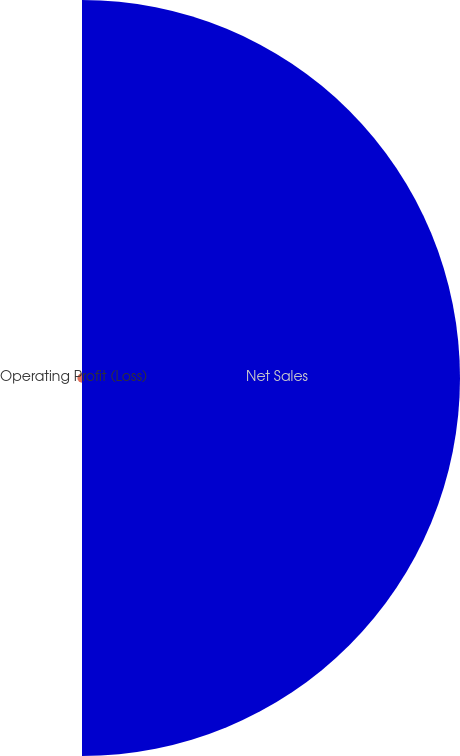Convert chart to OTSL. <chart><loc_0><loc_0><loc_500><loc_500><pie_chart><fcel>Net Sales<fcel>Operating Profit (Loss)<nl><fcel>98.79%<fcel>1.21%<nl></chart> 